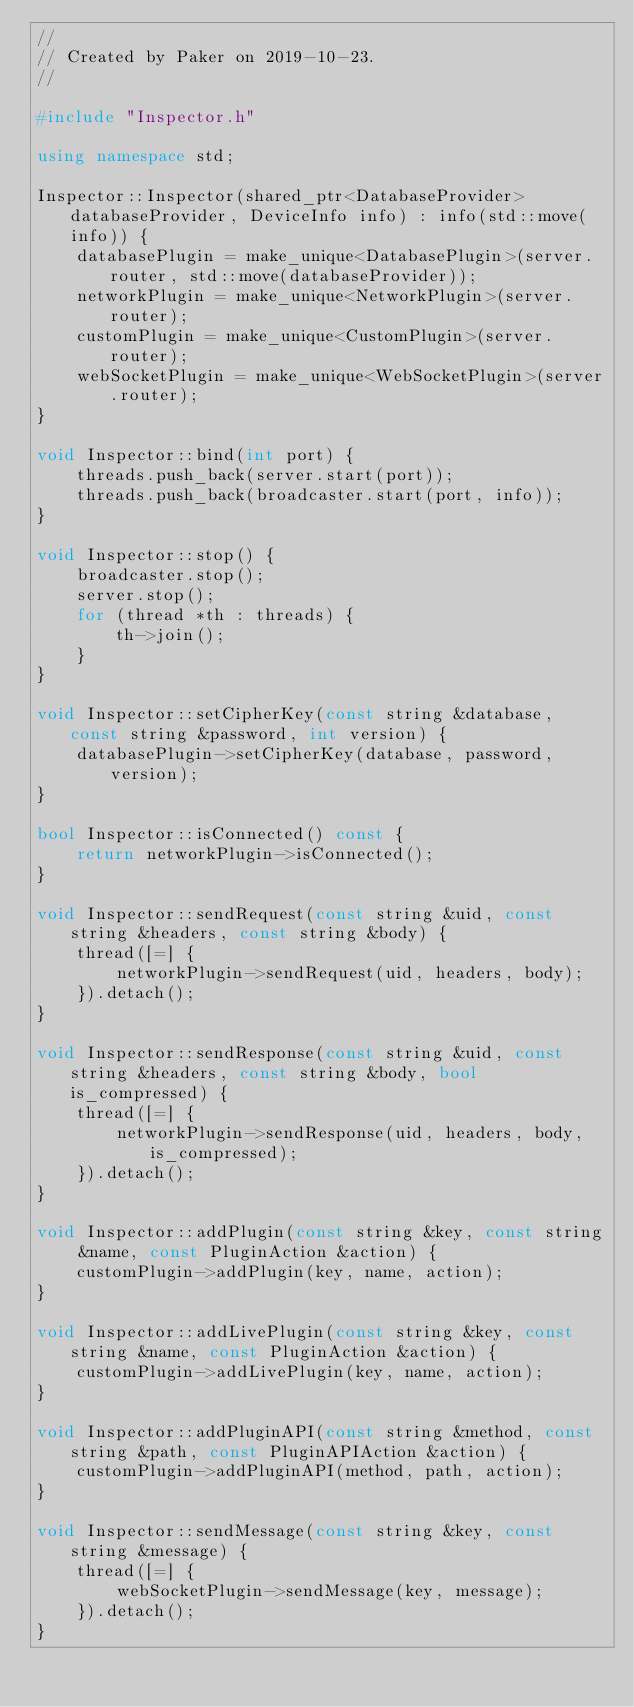<code> <loc_0><loc_0><loc_500><loc_500><_C++_>//
// Created by Paker on 2019-10-23.
//

#include "Inspector.h"

using namespace std;

Inspector::Inspector(shared_ptr<DatabaseProvider> databaseProvider, DeviceInfo info) : info(std::move(info)) {
    databasePlugin = make_unique<DatabasePlugin>(server.router, std::move(databaseProvider));
    networkPlugin = make_unique<NetworkPlugin>(server.router);
    customPlugin = make_unique<CustomPlugin>(server.router);
    webSocketPlugin = make_unique<WebSocketPlugin>(server.router);
}

void Inspector::bind(int port) {
    threads.push_back(server.start(port));
    threads.push_back(broadcaster.start(port, info));
}

void Inspector::stop() {
    broadcaster.stop();
    server.stop();
    for (thread *th : threads) {
        th->join();
    }
}

void Inspector::setCipherKey(const string &database, const string &password, int version) {
    databasePlugin->setCipherKey(database, password, version);
}

bool Inspector::isConnected() const {
    return networkPlugin->isConnected();
}

void Inspector::sendRequest(const string &uid, const string &headers, const string &body) {
    thread([=] {
        networkPlugin->sendRequest(uid, headers, body);
    }).detach();
}

void Inspector::sendResponse(const string &uid, const string &headers, const string &body, bool is_compressed) {
    thread([=] {
        networkPlugin->sendResponse(uid, headers, body, is_compressed);
    }).detach();
}

void Inspector::addPlugin(const string &key, const string &name, const PluginAction &action) {
    customPlugin->addPlugin(key, name, action);
}

void Inspector::addLivePlugin(const string &key, const string &name, const PluginAction &action) {
    customPlugin->addLivePlugin(key, name, action);
}

void Inspector::addPluginAPI(const string &method, const string &path, const PluginAPIAction &action) {
    customPlugin->addPluginAPI(method, path, action);
}

void Inspector::sendMessage(const string &key, const string &message) {
    thread([=] {
        webSocketPlugin->sendMessage(key, message);
    }).detach();
}
</code> 